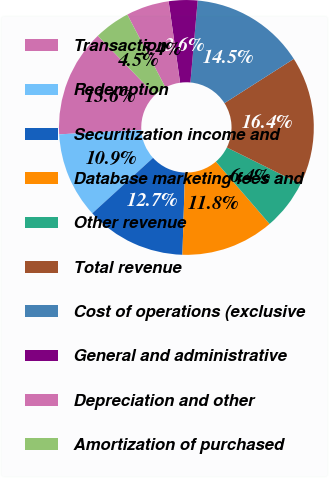<chart> <loc_0><loc_0><loc_500><loc_500><pie_chart><fcel>Transaction<fcel>Redemption<fcel>Securitization income and<fcel>Database marketing fees and<fcel>Other revenue<fcel>Total revenue<fcel>Cost of operations (exclusive<fcel>General and administrative<fcel>Depreciation and other<fcel>Amortization of purchased<nl><fcel>13.64%<fcel>10.91%<fcel>12.73%<fcel>11.82%<fcel>6.36%<fcel>16.36%<fcel>14.55%<fcel>3.64%<fcel>5.45%<fcel>4.55%<nl></chart> 